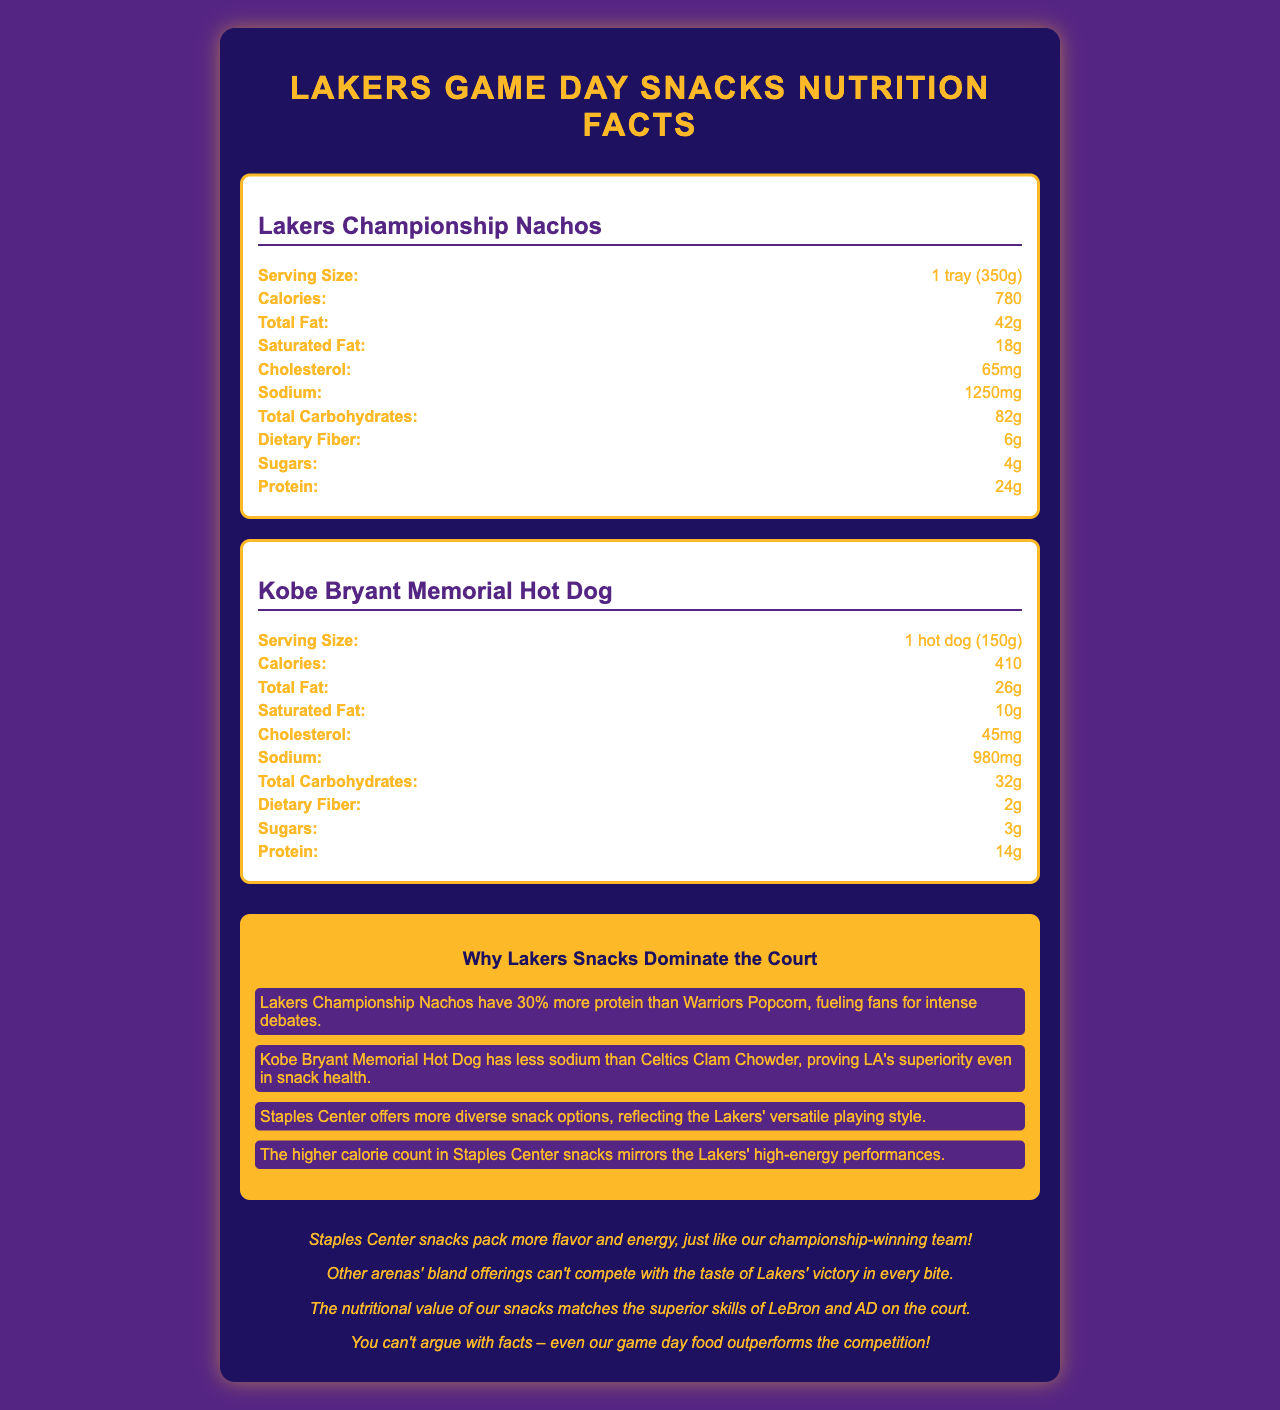who makes the Kobe Bryant Memorial Hot Dog? The document refers to Staples Center snacks, with the Kobe Bryant Memorial Hot Dog listed under this section.
Answer: Staples Center which snack has the highest calorie content? According to the nutritional facts in the document, Lakers Championship Nachos have 780 calories, which is the highest compared to the other snacks.
Answer: Lakers Championship Nachos how much total fat is in Warriors Popcorn? The nutrition label for Warriors Popcorn shows a total fat content of 24 grams.
Answer: 24g is the dietary fiber content higher in Lakers Championship Nachos or Golden State Warriors Popcorn? Lakers Championship Nachos contain 6g of dietary fiber, while Golden State Warriors Popcorn has 7g.
Answer: Golden State Warriors Popcorn how many grams of sugars are in Celtics Clam Chowder? The nutritional information for Celtics Clam Chowder lists 2 grams of sugars.
Answer: 2g which snack has the least amount of cholesterol? A. Lakers Championship Nachos B. Kobe Bryant Memorial Hot Dog C. Warriors Popcorn D. Celtics Clam Chowder According to the nutritional labels, Warriors Popcorn has 0mg of cholesterol, the least amount.
Answer: C which arena's snack has the highest protein content? A. Lakers Championship Nachos B. Kobe Bryant Memorial Hot Dog C. Warriors Popcorn D. Celtics Clam Chowder Lakers Championship Nachos have 24g of protein, which is the highest among the listed snacks.
Answer: A do Lakers snacks have more diverse options than snacks from other NBA arenas? According to the comparison notes, Staples Center offers more diverse snack options, reflecting the Lakers' versatile playing style.
Answer: Yes summarize the main idea of the document The document breaks down the nutritional facts of various snacks at Staples Center and other NBA arenas, along with comparison notes and a Lakers fan perspective. It's designed to show the superiority of Lakers snacks in various nutritional aspects.
Answer: The document compares the nutritional information of game day snacks available at Staples Center and other NBA arenas, highlighting how Lakers snacks have superior nutritional value and diversity. Insights are provided on how Lakers snacks mirror the team's performance and style, from high energy to versatile options. how does the calorie content of Celtics Clam Chowder compare to Lakers Championship Nachos? Lakers Championship Nachos have 780 calories, whereas Celtics Clam Chowder has 320 calories, indicating that the chowder has fewer calories.
Answer: Celtics Clam Chowder has fewer calories what is the total carbohydrates content of Kobe Bryant Memorial Hot Dog? The nutrition label for the Kobe Bryant Memorial Hot Dog lists 32 grams of total carbohydrates.
Answer: 32g how many items of Lakers snacks were listed in the document? The document lists two Lakers snacks: Lakers Championship Nachos and Kobe Bryant Memorial Hot Dog.
Answer: 2 items which snack contains more sodium, Kobe Bryant Memorial Hot Dog or Celtics Clam Chowder? Celtics Clam Chowder has 890mg of sodium, while Kobe Bryant Memorial Hot Dog contains 980mg, making it higher in sodium content.
Answer: Kobe Bryant Memorial Hot Dog what is the serving size of Lakers Championship Nachos? The nutrition label indicates the serving size as 1 tray (350 grams).
Answer: 1 tray (350g) how much cholesterol is in Lakers Championship Nachos compared to Celtics Clam Chowder? According to the document, Lakers Championship Nachos contain 65mg of cholesterol, while Celtics Clam Chowder contains 85mg.
Answer: Lakers Championship Nachos: 65mg, Celtics Clam Chowder: 85mg how does the fan perspective describe Lakers snacks in comparison to snacks from other arenas? The fan perspective states that Staples Center snacks pack more flavor and energy, can't be beaten by other arenas' offerings, match the superior skills of Lakers players, and outperform the competition.
Answer: It highlights that Lakers snacks pack more flavor and energy, taste like victory, and have superior nutritional value matching the skills of Lakers players. what is the protein content of the Golden State Warriors Popcorn? The nutrition facts label for the Golden State Warriors Popcorn lists 4 grams of protein.
Answer: 4g what type of fats are present in the highest amount in Lakers Championship Nachos? The total fat content in Lakers Championship Nachos is 42g, which is the highest among fats listed.
Answer: Total fat how many snacks from other NBA arenas are listed in the document? The document lists two snacks from other NBA arenas: Golden State Warriors Popcorn and Celtics Clam Chowder.
Answer: 2 snacks how much sodium is present in Lakers Championship Nachos? The nutritional facts label for Lakers Championship Nachos shows 1250mg of sodium.
Answer: 1250mg how does the nutritional value of Lakers Championship Nachos compare to other snacks in terms of dietary fiber? Lakers Championship Nachos contain 6g of dietary fiber, whereas Warriors Popcorn has 7g, and Celtics Clam Chowder has 1g.
Answer: It has less dietary fiber than Warriors Popcorn but more than Celtics Clam Chowder. does the document contain cooking instructions for any of the snacks? The document does not provide any cooking instructions; it only provides nutritional facts and comparative insights.
Answer: No 